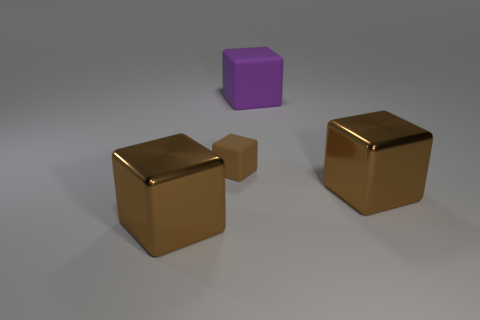What number of brown things are shiny blocks or big rubber objects?
Your response must be concise. 2. Are there an equal number of matte things that are behind the tiny object and large purple things that are left of the big purple object?
Give a very brief answer. No. There is a matte thing that is left of the purple block; is it the same shape as the large thing that is to the right of the big purple object?
Your answer should be compact. Yes. Are there any other things that are the same shape as the purple rubber object?
Ensure brevity in your answer.  Yes. What shape is the large purple thing that is made of the same material as the small brown thing?
Give a very brief answer. Cube. Is the number of brown rubber objects that are behind the purple matte thing the same as the number of green metal blocks?
Offer a very short reply. Yes. Does the object to the right of the purple object have the same material as the purple thing that is on the right side of the small brown rubber thing?
Keep it short and to the point. No. The large brown thing that is right of the brown metal object on the left side of the small thing is what shape?
Provide a short and direct response. Cube. The large cube that is made of the same material as the small object is what color?
Ensure brevity in your answer.  Purple. Is the small rubber block the same color as the large rubber object?
Give a very brief answer. No. 